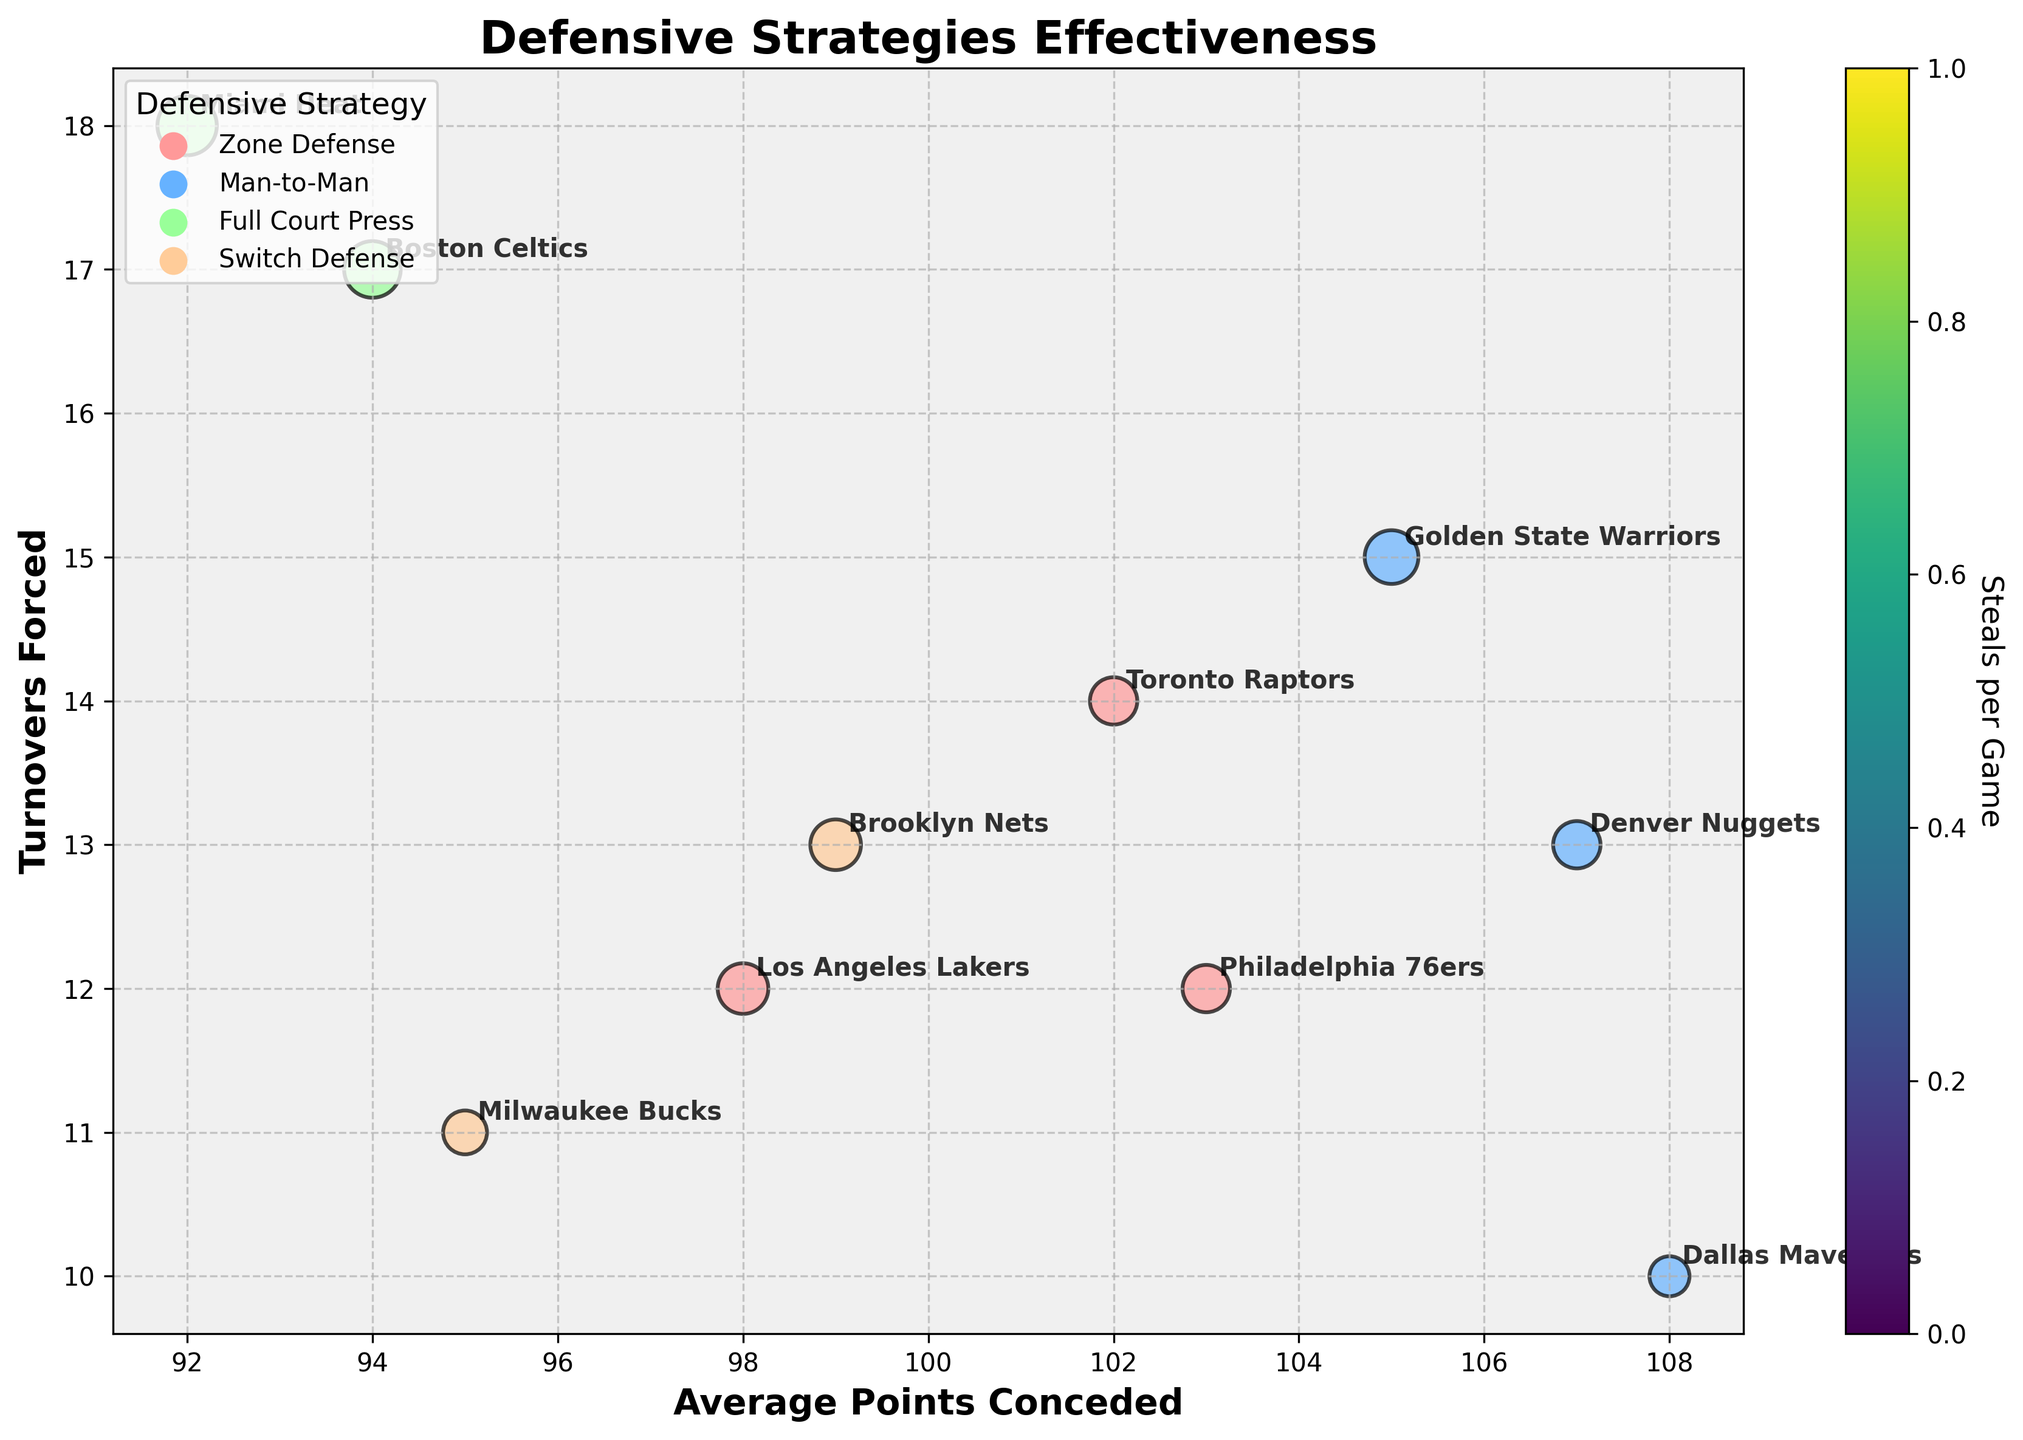What's the title of the bubble chart? The title is prominently displayed at the top of the chart, indicating the main focus of the visual.
Answer: Defensive Strategies Effectiveness Which team has the highest turnovers forced? Looking for the team positioned at the highest point on the Y-axis which represents turnovers forced.
Answer: Miami Heat Which defensive strategy is represented by green-colored bubbles? The plot's legend indicates the color-coding for each defensive strategy, with green associated with one of them.
Answer: Full Court Press How many teams use Zone Defense? By counting the bubbles colored according to the legend for Zone Defense.
Answer: 3 What's the average turnovers forced by teams using Man-to-Man defense? First, identify and list turnovers forced by teams using Man-to-Man defense, then calculate their average: (15 + 10 + 13) / 3 = 38 / 3 = 12.67
Answer: 12.67 Which team conceded the least average points? Locate the bubble furthest to the left on the X-axis, which represents average points conceded.
Answer: Miami Heat Compare the average points conceded by Toronto Raptors and Brooklyn Nets. Which team concedes more? Locate the corresponding bubbles on the X-axis; compare their positions.
Answer: Toronto Raptors Which defensive strategy generally leads to higher turnovers forced, and name the teams using it? Compare the Y-axis positions of the bubbles according to defensive strategies; look for those higher up.
Answer: Full Court Press (Miami Heat, Boston Celtics) What's the correlation between average points conceded and steals per game among teams using Switch Defense? Analyze the positions of Brooklyn Nets and Milwaukee Bucks on the X-axis (average points conceded) and their bubble sizes (steals per game) to assess if any apparent pattern or direct correlation is observable.
Answer: No clear correlation How does the Boston Celtics' defensive performance compare to the Los Angeles Lakers in terms of turnovers forced and average points conceded? Locate their respective bubbles and compare Y-axis (turnovers forced) and X-axis (average points conceded); Celtics are higher on Y-axis and close on X-axis.
Answer: Higher turnovers, similar points 